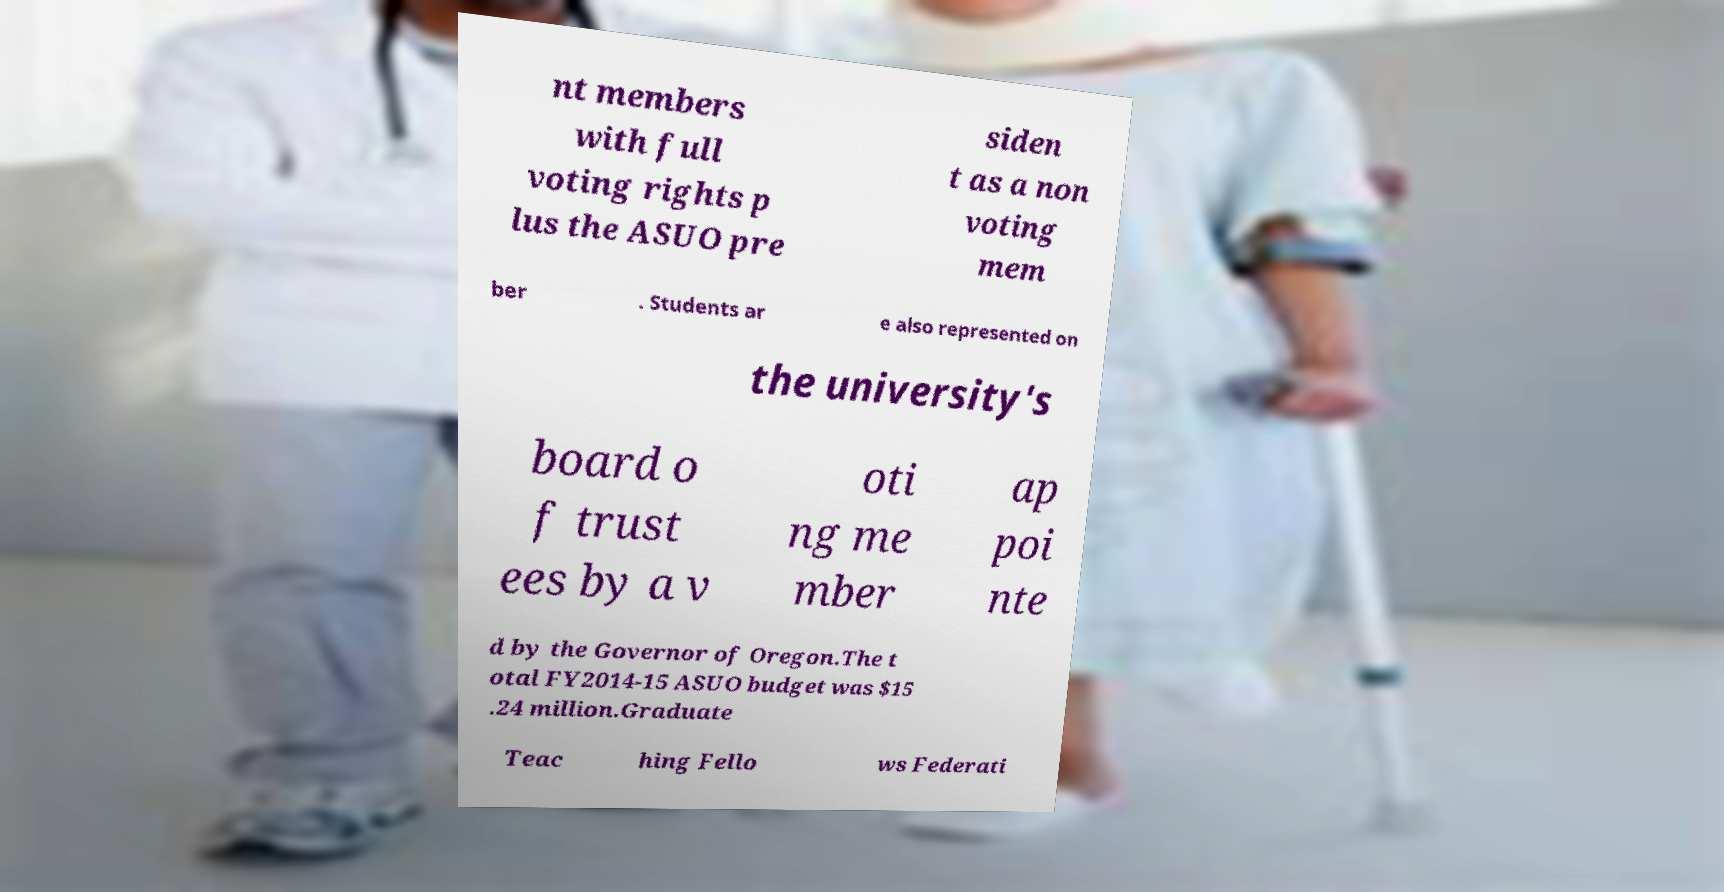Could you assist in decoding the text presented in this image and type it out clearly? nt members with full voting rights p lus the ASUO pre siden t as a non voting mem ber . Students ar e also represented on the university's board o f trust ees by a v oti ng me mber ap poi nte d by the Governor of Oregon.The t otal FY2014-15 ASUO budget was $15 .24 million.Graduate Teac hing Fello ws Federati 